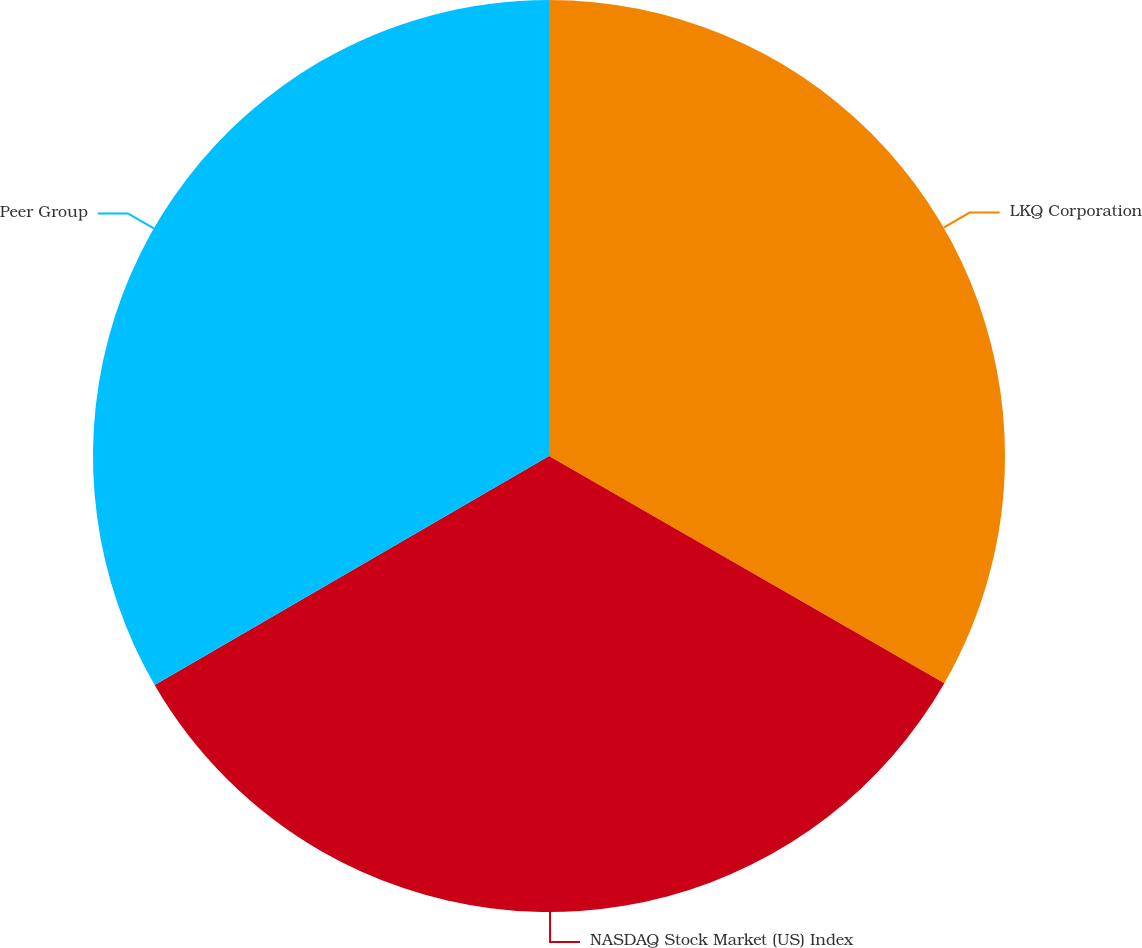Convert chart to OTSL. <chart><loc_0><loc_0><loc_500><loc_500><pie_chart><fcel>LKQ Corporation<fcel>NASDAQ Stock Market (US) Index<fcel>Peer Group<nl><fcel>33.3%<fcel>33.33%<fcel>33.37%<nl></chart> 